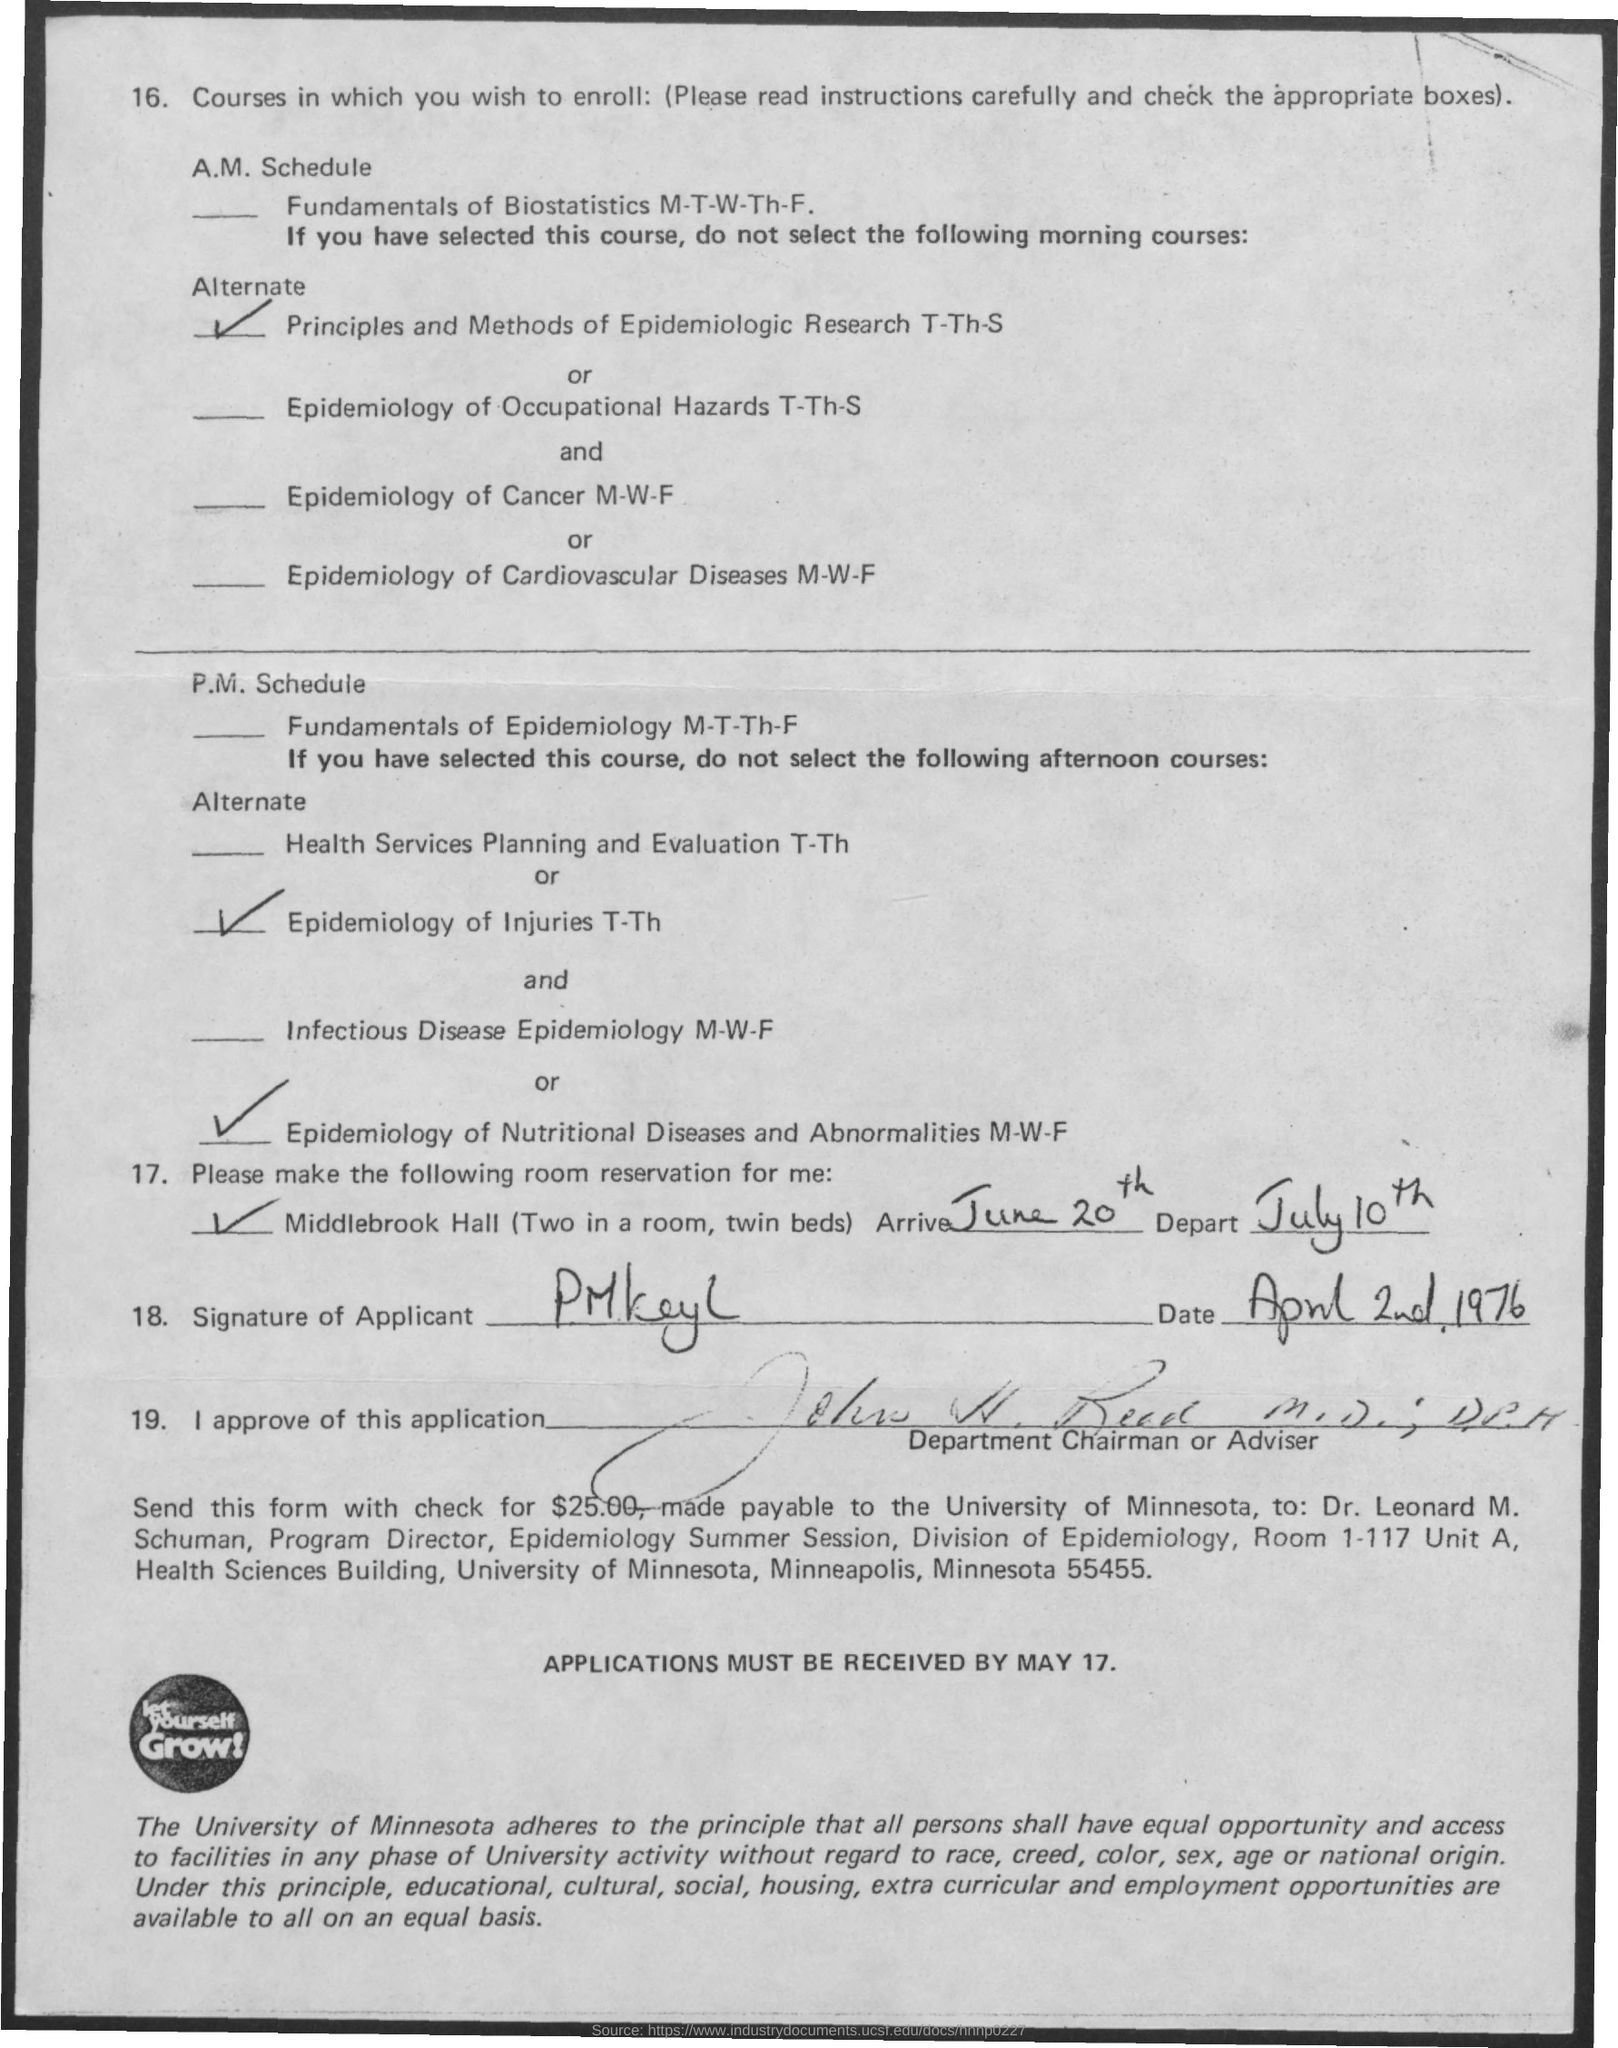List a handful of essential elements in this visual. The depart date mentioned in the given letter is July 10th. The arrival date mentioned in the given letter is June 20th. The signature on the letter was done on April 2nd, 1976. 